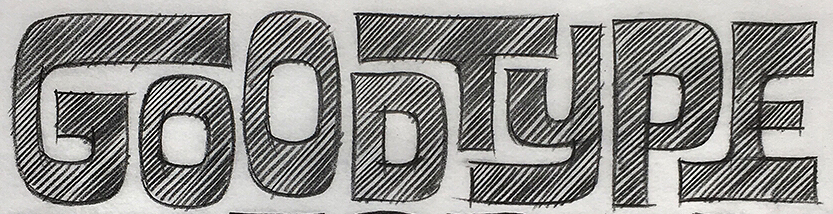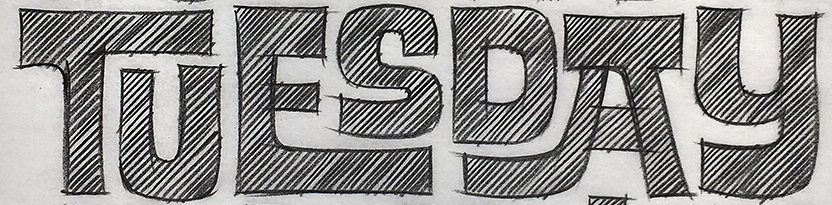Read the text from these images in sequence, separated by a semicolon. GOODTYPE; TUESDAY 